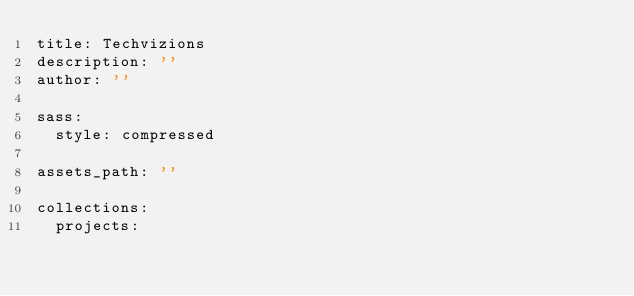Convert code to text. <code><loc_0><loc_0><loc_500><loc_500><_YAML_>title: Techvizions
description: ''
author: ''

sass:
  style: compressed

assets_path: '' 

collections:
  projects:
</code> 